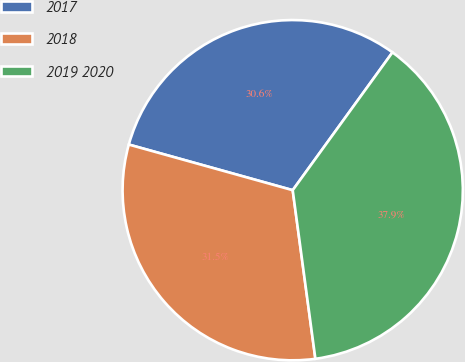Convert chart to OTSL. <chart><loc_0><loc_0><loc_500><loc_500><pie_chart><fcel>2017<fcel>2018<fcel>2019 2020<nl><fcel>30.65%<fcel>31.45%<fcel>37.9%<nl></chart> 